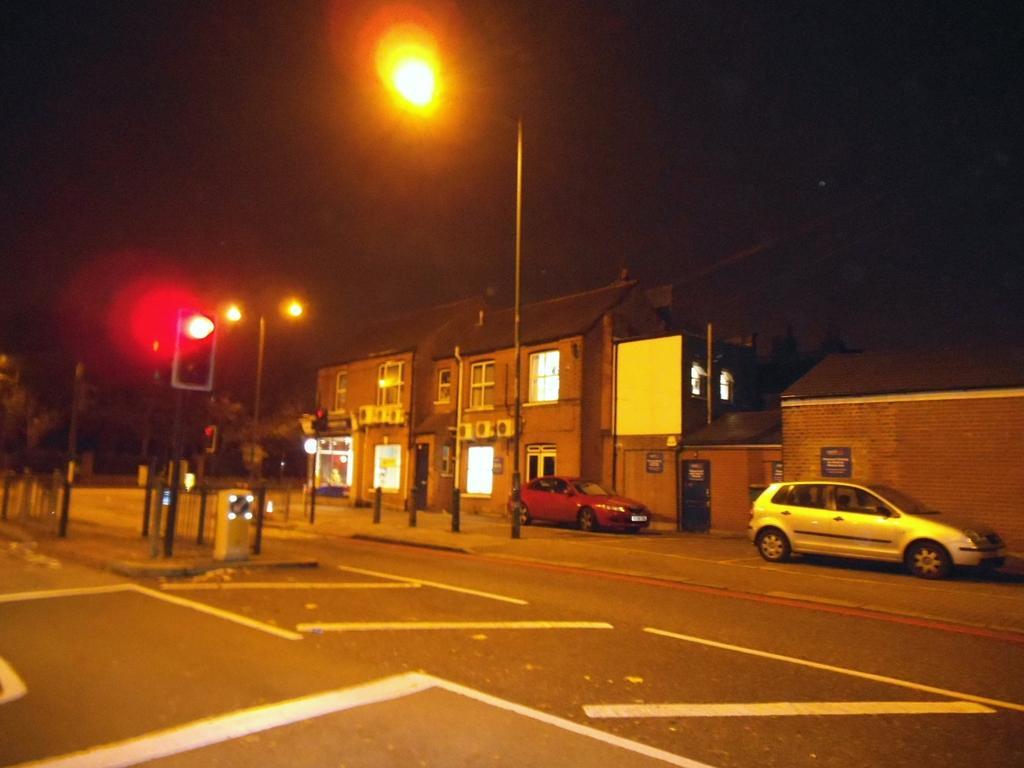How would you summarize this image in a sentence or two? In this picture we can see poles, lights, traffic signal, boards, trees, and buildings. There are cars on the road. In the background there is sky. 